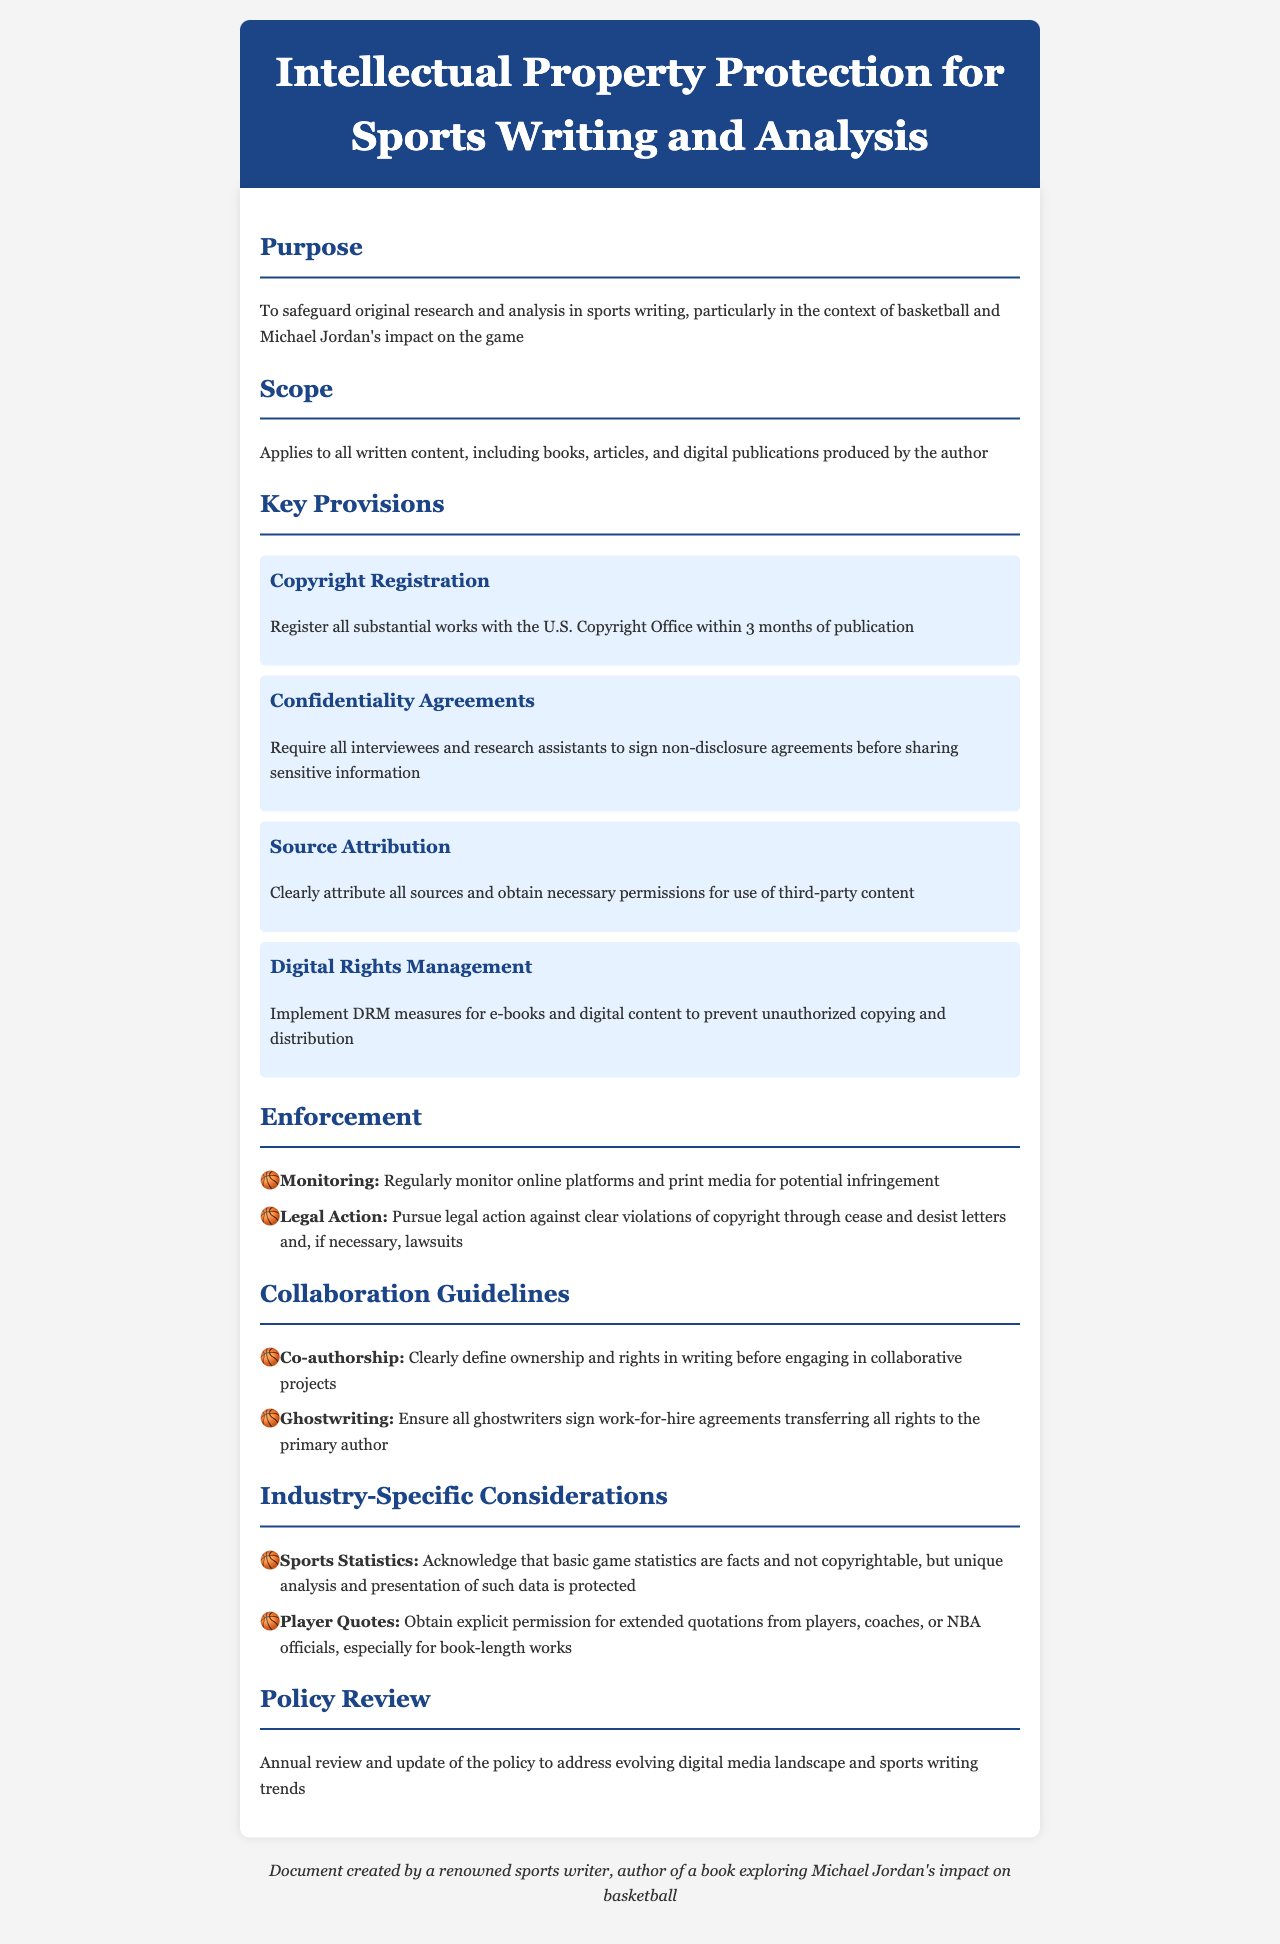What is the purpose of the policy? The purpose is to safeguard original research and analysis in sports writing, particularly in the context of basketball and Michael Jordan's impact on the game.
Answer: To safeguard original research and analysis in sports writing What is the scope of the policy? The scope applies to all written content, including books, articles, and digital publications produced by the author.
Answer: All written content, including books, articles, and digital publications Within how many months must works be registered with the U.S. Copyright Office? The document states that substantial works should be registered within 3 months of publication.
Answer: 3 months What is required from interviewees and research assistants? The document mandates that all interviewees and research assistants must sign non-disclosure agreements before sharing sensitive information.
Answer: Non-disclosure agreements What should be done for extended quotations from players? The document specifies that explicit permission must be obtained for extended quotations from players, coaches, or NBA officials, especially for book-length works.
Answer: Obtain explicit permission What kind of agreements should ghostwriters sign? Ghostwriters are required to sign work-for-hire agreements transferring all rights to the primary author.
Answer: Work-for-hire agreements How often is the policy reviewed and updated? The document states that the policy undergoes an annual review and update.
Answer: Annually 